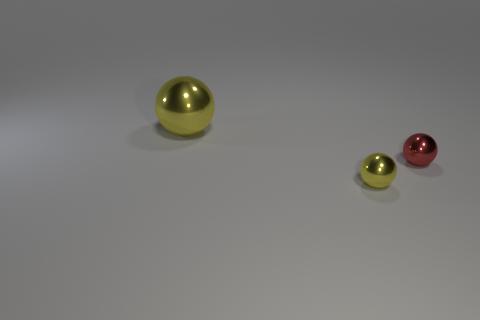Add 3 yellow shiny things. How many objects exist? 6 Subtract all tiny metallic things. Subtract all small yellow metallic things. How many objects are left? 0 Add 1 tiny yellow spheres. How many tiny yellow spheres are left? 2 Add 3 big spheres. How many big spheres exist? 4 Subtract 0 yellow blocks. How many objects are left? 3 